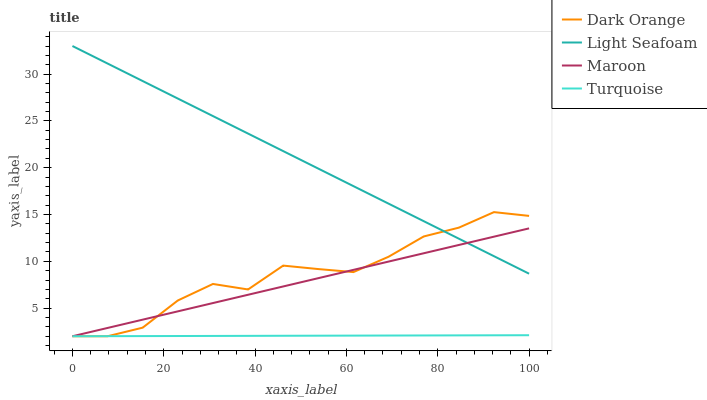Does Turquoise have the minimum area under the curve?
Answer yes or no. Yes. Does Light Seafoam have the maximum area under the curve?
Answer yes or no. Yes. Does Light Seafoam have the minimum area under the curve?
Answer yes or no. No. Does Turquoise have the maximum area under the curve?
Answer yes or no. No. Is Turquoise the smoothest?
Answer yes or no. Yes. Is Dark Orange the roughest?
Answer yes or no. Yes. Is Light Seafoam the smoothest?
Answer yes or no. No. Is Light Seafoam the roughest?
Answer yes or no. No. Does Dark Orange have the lowest value?
Answer yes or no. Yes. Does Light Seafoam have the lowest value?
Answer yes or no. No. Does Light Seafoam have the highest value?
Answer yes or no. Yes. Does Turquoise have the highest value?
Answer yes or no. No. Is Turquoise less than Light Seafoam?
Answer yes or no. Yes. Is Light Seafoam greater than Turquoise?
Answer yes or no. Yes. Does Light Seafoam intersect Maroon?
Answer yes or no. Yes. Is Light Seafoam less than Maroon?
Answer yes or no. No. Is Light Seafoam greater than Maroon?
Answer yes or no. No. Does Turquoise intersect Light Seafoam?
Answer yes or no. No. 